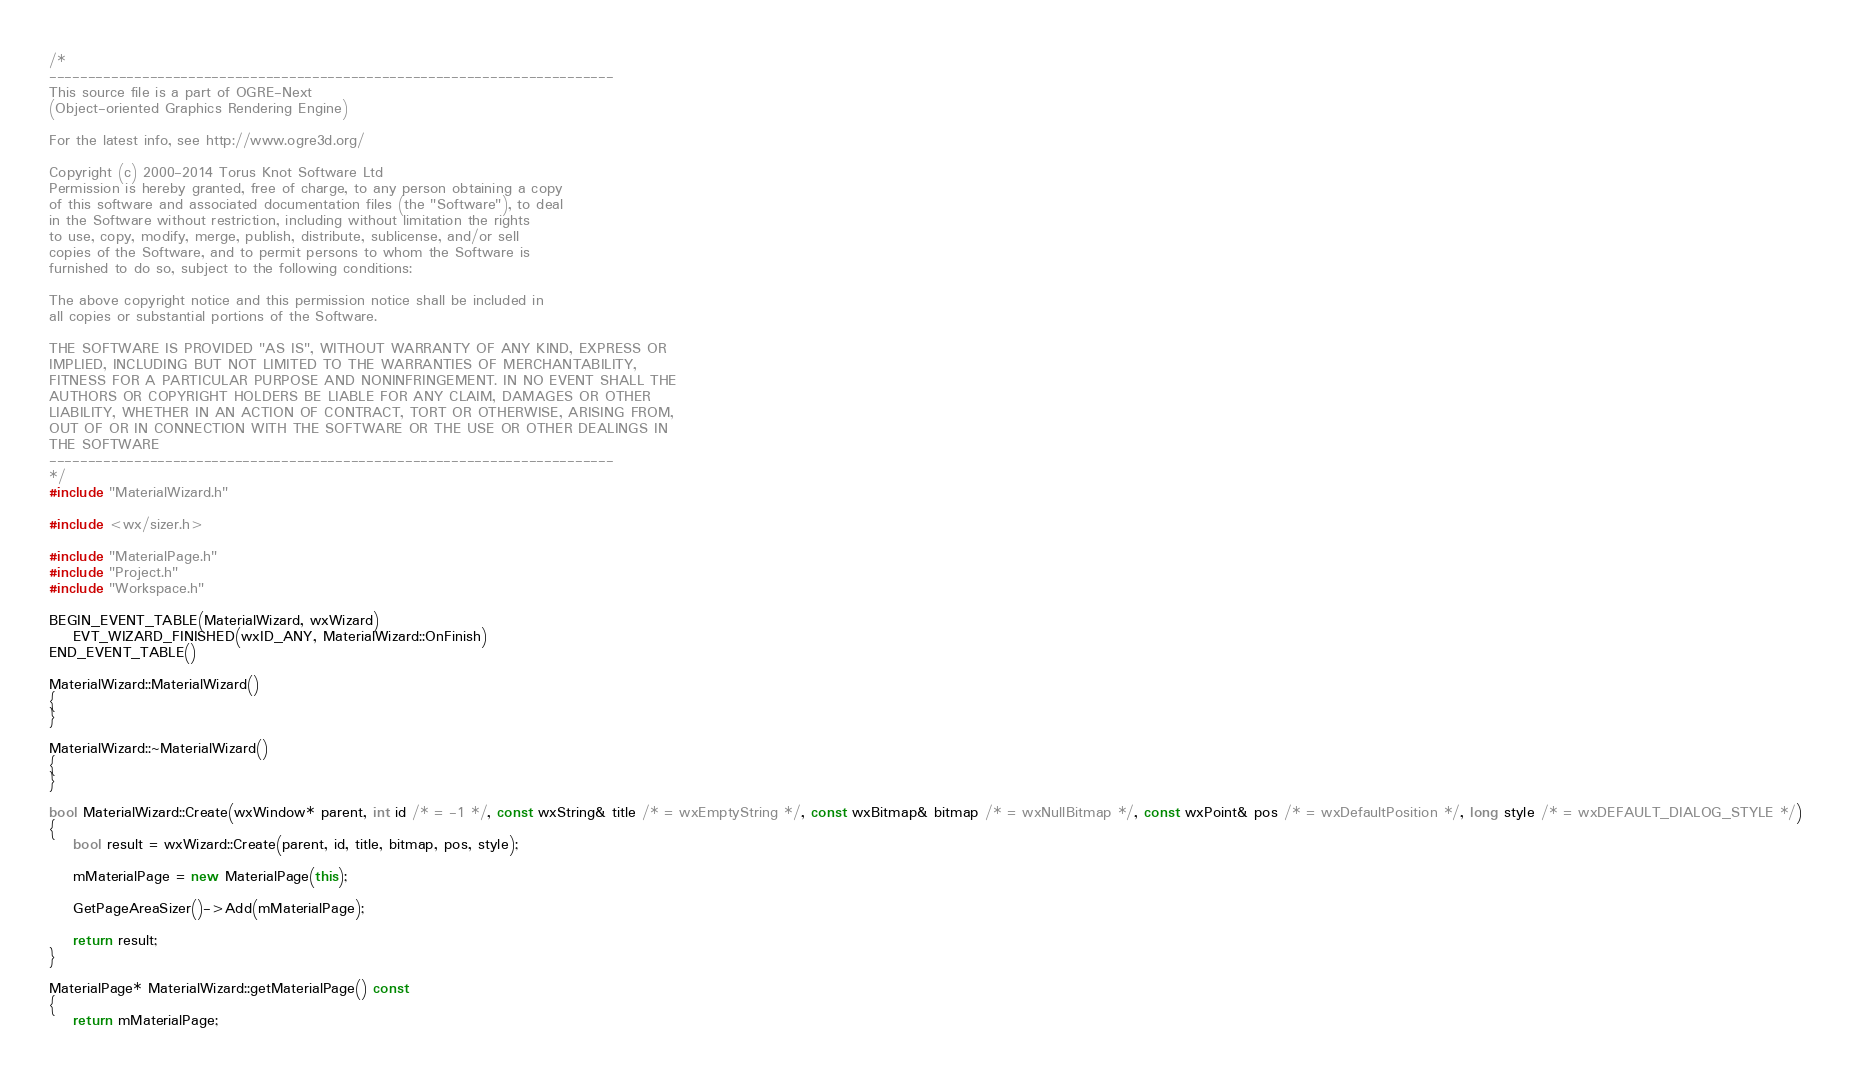<code> <loc_0><loc_0><loc_500><loc_500><_C++_>/*
-------------------------------------------------------------------------
This source file is a part of OGRE-Next
(Object-oriented Graphics Rendering Engine)

For the latest info, see http://www.ogre3d.org/

Copyright (c) 2000-2014 Torus Knot Software Ltd
Permission is hereby granted, free of charge, to any person obtaining a copy
of this software and associated documentation files (the "Software"), to deal
in the Software without restriction, including without limitation the rights
to use, copy, modify, merge, publish, distribute, sublicense, and/or sell
copies of the Software, and to permit persons to whom the Software is
furnished to do so, subject to the following conditions:

The above copyright notice and this permission notice shall be included in
all copies or substantial portions of the Software.

THE SOFTWARE IS PROVIDED "AS IS", WITHOUT WARRANTY OF ANY KIND, EXPRESS OR
IMPLIED, INCLUDING BUT NOT LIMITED TO THE WARRANTIES OF MERCHANTABILITY,
FITNESS FOR A PARTICULAR PURPOSE AND NONINFRINGEMENT. IN NO EVENT SHALL THE
AUTHORS OR COPYRIGHT HOLDERS BE LIABLE FOR ANY CLAIM, DAMAGES OR OTHER
LIABILITY, WHETHER IN AN ACTION OF CONTRACT, TORT OR OTHERWISE, ARISING FROM,
OUT OF OR IN CONNECTION WITH THE SOFTWARE OR THE USE OR OTHER DEALINGS IN
THE SOFTWARE
-------------------------------------------------------------------------
*/
#include "MaterialWizard.h"

#include <wx/sizer.h>

#include "MaterialPage.h"
#include "Project.h"
#include "Workspace.h"

BEGIN_EVENT_TABLE(MaterialWizard, wxWizard)
    EVT_WIZARD_FINISHED(wxID_ANY, MaterialWizard::OnFinish)
END_EVENT_TABLE()

MaterialWizard::MaterialWizard()
{
}

MaterialWizard::~MaterialWizard()
{
}

bool MaterialWizard::Create(wxWindow* parent, int id /* = -1 */, const wxString& title /* = wxEmptyString */, const wxBitmap& bitmap /* = wxNullBitmap */, const wxPoint& pos /* = wxDefaultPosition */, long style /* = wxDEFAULT_DIALOG_STYLE */)
{
    bool result = wxWizard::Create(parent, id, title, bitmap, pos, style);

    mMaterialPage = new MaterialPage(this);

    GetPageAreaSizer()->Add(mMaterialPage);

    return result;
}

MaterialPage* MaterialWizard::getMaterialPage() const
{
    return mMaterialPage;</code> 